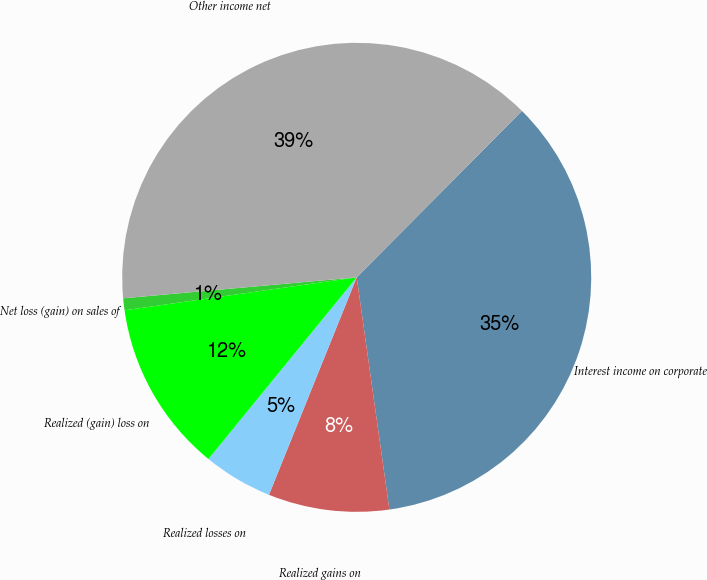<chart> <loc_0><loc_0><loc_500><loc_500><pie_chart><fcel>Interest income on corporate<fcel>Realized gains on<fcel>Realized losses on<fcel>Realized (gain) loss on<fcel>Net loss (gain) on sales of<fcel>Other income net<nl><fcel>35.33%<fcel>8.33%<fcel>4.79%<fcel>11.86%<fcel>0.82%<fcel>38.87%<nl></chart> 